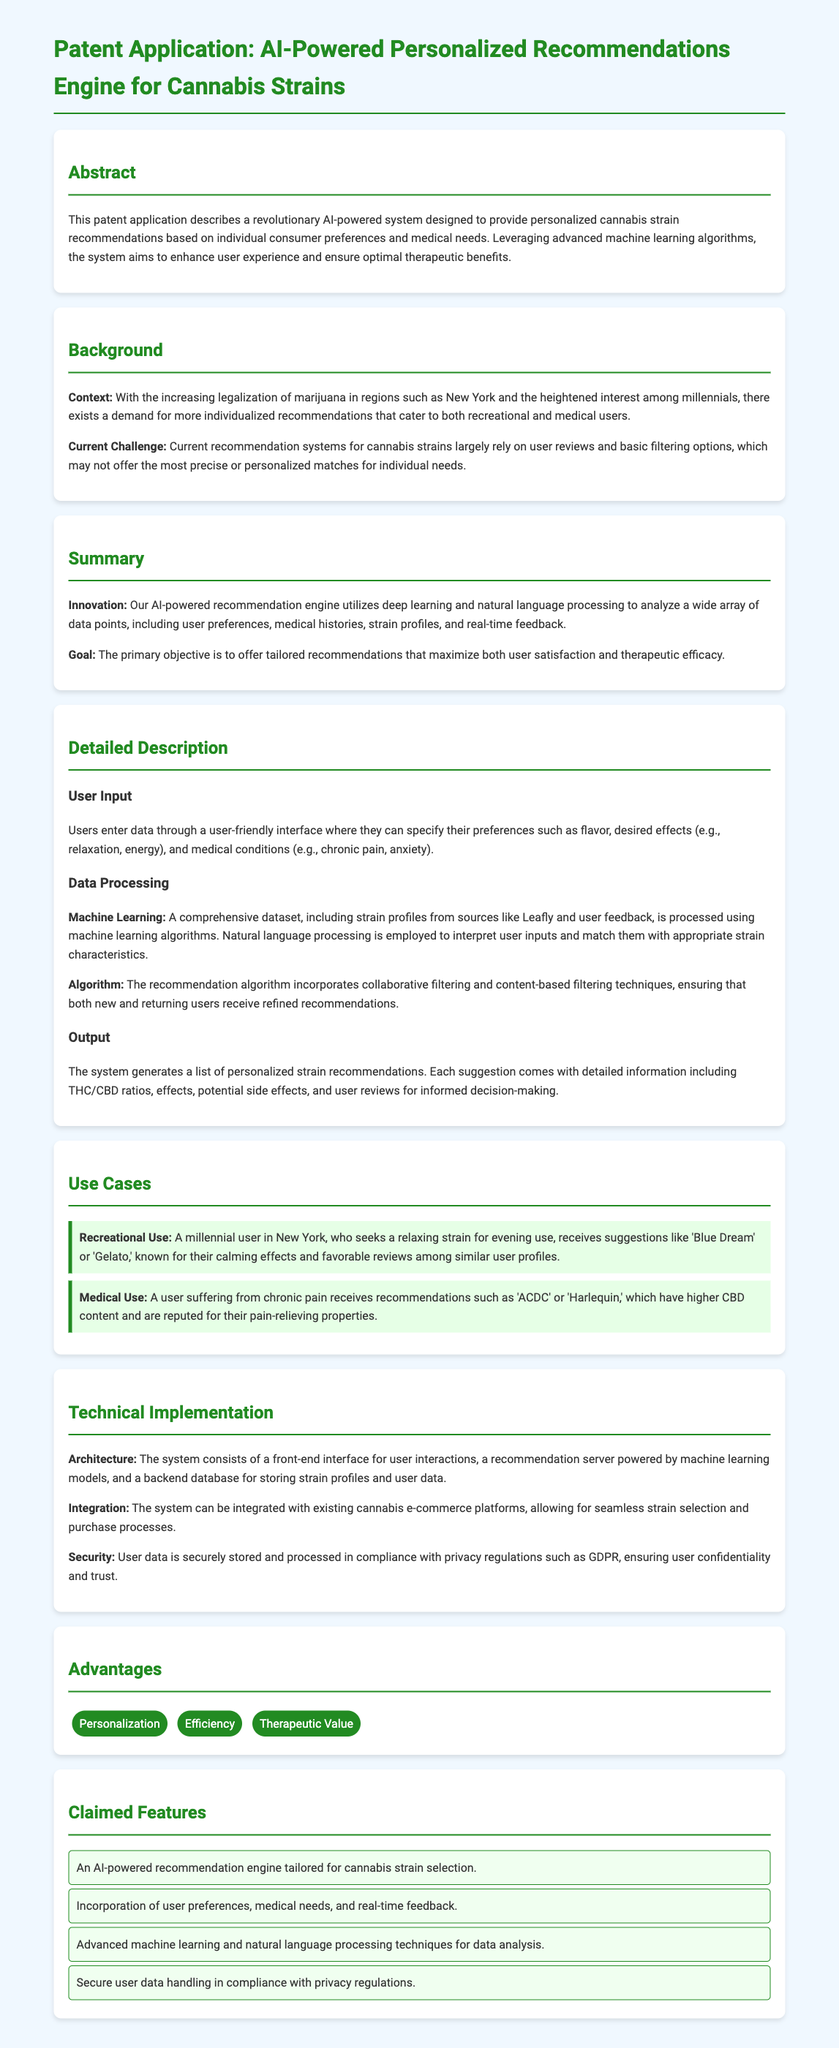What is the main purpose of the AI-powered system? The main purpose of the system is to provide personalized cannabis strain recommendations based on consumer preferences and medical needs.
Answer: personalized cannabis strain recommendations What techniques are utilized for data analysis in this system? The document specifies that advanced machine learning and natural language processing techniques are used for data analysis.
Answer: machine learning and natural language processing Which strains are recommended for recreational use? The document lists 'Blue Dream' and 'Gelato' as recommendations for recreational use.
Answer: Blue Dream, Gelato What is the user input requirement? Users must specify their preferences such as flavor, desired effects, and medical conditions through a user-friendly interface.
Answer: specify preferences How does the recommendation algorithm work? The recommendation algorithm incorporates collaborative filtering and content-based filtering techniques.
Answer: collaborative filtering and content-based filtering What privacy regulations does the system comply with? The system is stated to comply with GDPR for secure user data handling.
Answer: GDPR What type of users is targeted by this recommendation engine? The targeted users include both recreational and medical users of cannabis.
Answer: recreational and medical users What feature is highlighted under 'Advantages'? Personalization is highlighted as a key advantage of the recommendation system.
Answer: Personalization 